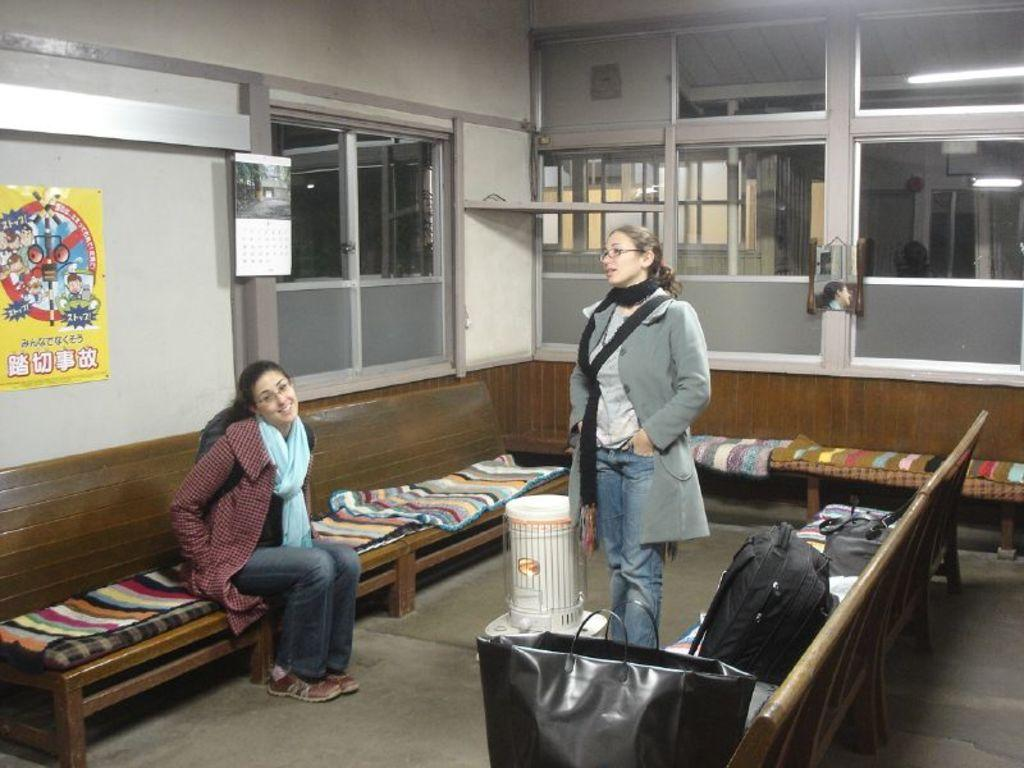What is the lady in the image doing? The lady is sitting on a bench in the image. What is on the bench with the lady? There is a cloth on the bench. Can you describe the person near the bench? There is another person near the bench. What type of bags can be seen in the image? A backpack and a bag are visible in the image. What is on the walls in the image? There are posters on the walls in the image. How many lizards are crawling on the lady's arm in the image? There are no lizards present in the image. What type of sound can be heard coming from the backpack in the image? There is no sound coming from the backpack in the image, as it is an inanimate object. 